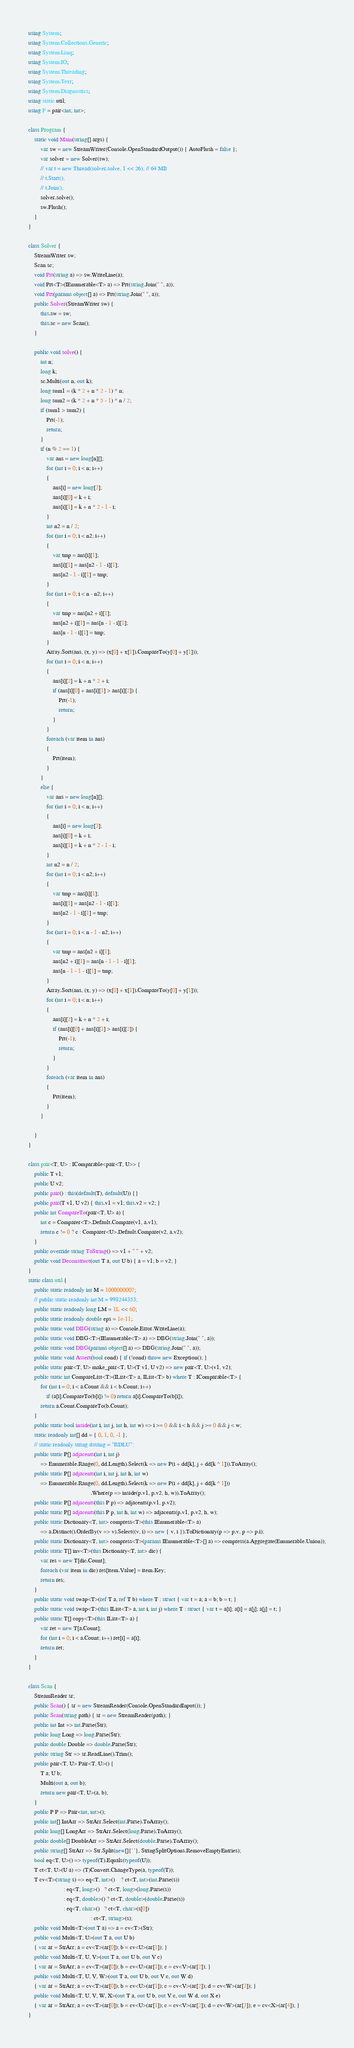<code> <loc_0><loc_0><loc_500><loc_500><_C#_>using System;
using System.Collections.Generic;
using System.Linq;
using System.IO;
using System.Threading;
using System.Text;
using System.Diagnostics;
using static util;
using P = pair<int, int>;

class Program {
    static void Main(string[] args) {
        var sw = new StreamWriter(Console.OpenStandardOutput()) { AutoFlush = false };
        var solver = new Solver(sw);
        // var t = new Thread(solver.solve, 1 << 26); // 64 MB
        // t.Start();
        // t.Join();
        solver.solve();
        sw.Flush();
    }
}

class Solver {
    StreamWriter sw;
    Scan sc;
    void Prt(string a) => sw.WriteLine(a);
    void Prt<T>(IEnumerable<T> a) => Prt(string.Join(" ", a));
    void Prt(params object[] a) => Prt(string.Join(" ", a));
    public Solver(StreamWriter sw) {
        this.sw = sw;
        this.sc = new Scan();
    }

    public void solve() {
        int n;
        long k;
        sc.Multi(out n, out k);
        long sum1 = (k * 2 + n * 2 - 1) * n;
        long sum2 = (k * 2 + n * 5 - 1) * n / 2;
        if (sum1 > sum2) {
            Prt(-1);
            return;
        }
        if (n % 2 == 1) {
            var ans = new long[n][];
            for (int i = 0; i < n; i++)
            {
                ans[i] = new long[3];
                ans[i][0] = k + i;
                ans[i][1] = k + n * 2 - 1 - i;
            }
            int n2 = n / 2;
            for (int i = 0; i < n2; i++)
            {
                var tmp = ans[i][1];
                ans[i][1] = ans[n2 - 1 - i][1];
                ans[n2 - 1 - i][1] = tmp;
            }
            for (int i = 0; i < n - n2; i++)
            {
                var tmp = ans[n2 + i][1];
                ans[n2 + i][1] = ans[n - 1 - i][1];
                ans[n - 1 - i][1] = tmp;
            }
            Array.Sort(ans, (x, y) => (x[0] + x[1]).CompareTo(y[0] + y[1]));
            for (int i = 0; i < n; i++)
            {
                ans[i][2] = k + n * 2 + i;
                if (ans[i][0] + ans[i][1] > ans[i][2]) {
                    Prt(-1);
                    return;
                }
            }
            foreach (var item in ans)
            {
                Prt(item);
            }
        }
        else {
            var ans = new long[n][];
            for (int i = 0; i < n; i++)
            {
                ans[i] = new long[3];
                ans[i][0] = k + i;
                ans[i][1] = k + n * 2 - 1 - i;
            }
            int n2 = n / 2;
            for (int i = 0; i < n2; i++)
            {
                var tmp = ans[i][1];
                ans[i][1] = ans[n2 - 1 - i][1];
                ans[n2 - 1 - i][1] = tmp;
            }
            for (int i = 0; i < n - 1 - n2; i++)
            {
                var tmp = ans[n2 + i][1];
                ans[n2 + i][1] = ans[n - 1 - 1 - i][1];
                ans[n - 1 - 1 - i][1] = tmp;
            }
            Array.Sort(ans, (x, y) => (x[0] + x[1]).CompareTo(y[0] + y[1]));
            for (int i = 0; i < n; i++)
            {
                ans[i][2] = k + n * 2 + i;
                if (ans[i][0] + ans[i][1] > ans[i][2]) {
                    Prt(-1);
                    return;
                }
            }
            foreach (var item in ans)
            {
                Prt(item);
            }
        }

    }
}

class pair<T, U> : IComparable<pair<T, U>> {
    public T v1;
    public U v2;
    public pair() : this(default(T), default(U)) {}
    public pair(T v1, U v2) { this.v1 = v1; this.v2 = v2; }
    public int CompareTo(pair<T, U> a) {
        int c = Comparer<T>.Default.Compare(v1, a.v1);
        return c != 0 ? c : Comparer<U>.Default.Compare(v2, a.v2);
    }
    public override string ToString() => v1 + " " + v2;
    public void Deconstruct(out T a, out U b) { a = v1; b = v2; }
}
static class util {
    public static readonly int M = 1000000007;
    // public static readonly int M = 998244353;
    public static readonly long LM = 1L << 60;
    public static readonly double eps = 1e-11;
    public static void DBG(string a) => Console.Error.WriteLine(a);
    public static void DBG<T>(IEnumerable<T> a) => DBG(string.Join(" ", a));
    public static void DBG(params object[] a) => DBG(string.Join(" ", a));
    public static void Assert(bool cond) { if (!cond) throw new Exception(); }
    public static pair<T, U> make_pair<T, U>(T v1, U v2) => new pair<T, U>(v1, v2);
    public static int CompareList<T>(IList<T> a, IList<T> b) where T : IComparable<T> {
        for (int i = 0; i < a.Count && i < b.Count; i++)
            if (a[i].CompareTo(b[i]) != 0) return a[i].CompareTo(b[i]);
        return a.Count.CompareTo(b.Count);
    }
    public static bool inside(int i, int j, int h, int w) => i >= 0 && i < h && j >= 0 && j < w;
    static readonly int[] dd = { 0, 1, 0, -1 };
    // static readonly string dstring = "RDLU";
    public static P[] adjacents(int i, int j)
        => Enumerable.Range(0, dd.Length).Select(k => new P(i + dd[k], j + dd[k ^ 1])).ToArray();
    public static P[] adjacents(int i, int j, int h, int w)
        => Enumerable.Range(0, dd.Length).Select(k => new P(i + dd[k], j + dd[k ^ 1]))
                                         .Where(p => inside(p.v1, p.v2, h, w)).ToArray();
    public static P[] adjacents(this P p) => adjacents(p.v1, p.v2);
    public static P[] adjacents(this P p, int h, int w) => adjacents(p.v1, p.v2, h, w);
    public static Dictionary<T, int> compress<T>(this IEnumerable<T> a)
        => a.Distinct().OrderBy(v => v).Select((v, i) => new { v, i }).ToDictionary(p => p.v, p => p.i);
    public static Dictionary<T, int> compress<T>(params IEnumerable<T>[] a) => compress(a.Aggregate(Enumerable.Union));
    public static T[] inv<T>(this Dictionary<T, int> dic) {
        var res = new T[dic.Count];
        foreach (var item in dic) res[item.Value] = item.Key;
        return res;
    }
    public static void swap<T>(ref T a, ref T b) where T : struct { var t = a; a = b; b = t; }
    public static void swap<T>(this IList<T> a, int i, int j) where T : struct { var t = a[i]; a[i] = a[j]; a[j] = t; }
    public static T[] copy<T>(this IList<T> a) {
        var ret = new T[a.Count];
        for (int i = 0; i < a.Count; i++) ret[i] = a[i];
        return ret;
    }
}

class Scan {
    StreamReader sr;
    public Scan() { sr = new StreamReader(Console.OpenStandardInput()); }
    public Scan(string path) { sr = new StreamReader(path); }
    public int Int => int.Parse(Str);
    public long Long => long.Parse(Str);
    public double Double => double.Parse(Str);
    public string Str => sr.ReadLine().Trim();
    public pair<T, U> Pair<T, U>() {
        T a; U b;
        Multi(out a, out b);
        return new pair<T, U>(a, b);
    }
    public P P => Pair<int, int>();
    public int[] IntArr => StrArr.Select(int.Parse).ToArray();
    public long[] LongArr => StrArr.Select(long.Parse).ToArray();
    public double[] DoubleArr => StrArr.Select(double.Parse).ToArray();
    public string[] StrArr => Str.Split(new[]{' '}, StringSplitOptions.RemoveEmptyEntries);
    bool eq<T, U>() => typeof(T).Equals(typeof(U));
    T ct<T, U>(U a) => (T)Convert.ChangeType(a, typeof(T));
    T cv<T>(string s) => eq<T, int>()    ? ct<T, int>(int.Parse(s))
                       : eq<T, long>()   ? ct<T, long>(long.Parse(s))
                       : eq<T, double>() ? ct<T, double>(double.Parse(s))
                       : eq<T, char>()   ? ct<T, char>(s[0])
                                         : ct<T, string>(s);
    public void Multi<T>(out T a) => a = cv<T>(Str);
    public void Multi<T, U>(out T a, out U b)
    { var ar = StrArr; a = cv<T>(ar[0]); b = cv<U>(ar[1]); }
    public void Multi<T, U, V>(out T a, out U b, out V c)
    { var ar = StrArr; a = cv<T>(ar[0]); b = cv<U>(ar[1]); c = cv<V>(ar[2]); }
    public void Multi<T, U, V, W>(out T a, out U b, out V c, out W d)
    { var ar = StrArr; a = cv<T>(ar[0]); b = cv<U>(ar[1]); c = cv<V>(ar[2]); d = cv<W>(ar[3]); }
    public void Multi<T, U, V, W, X>(out T a, out U b, out V c, out W d, out X e)
    { var ar = StrArr; a = cv<T>(ar[0]); b = cv<U>(ar[1]); c = cv<V>(ar[2]); d = cv<W>(ar[3]); e = cv<X>(ar[4]); }
}
</code> 